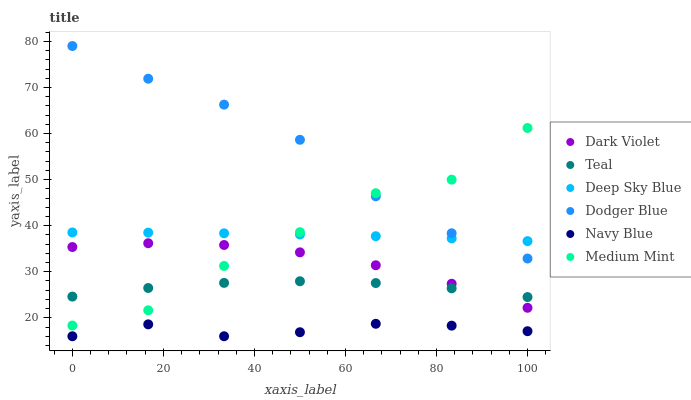Does Navy Blue have the minimum area under the curve?
Answer yes or no. Yes. Does Dodger Blue have the maximum area under the curve?
Answer yes or no. Yes. Does Teal have the minimum area under the curve?
Answer yes or no. No. Does Teal have the maximum area under the curve?
Answer yes or no. No. Is Deep Sky Blue the smoothest?
Answer yes or no. Yes. Is Medium Mint the roughest?
Answer yes or no. Yes. Is Teal the smoothest?
Answer yes or no. No. Is Teal the roughest?
Answer yes or no. No. Does Navy Blue have the lowest value?
Answer yes or no. Yes. Does Teal have the lowest value?
Answer yes or no. No. Does Dodger Blue have the highest value?
Answer yes or no. Yes. Does Teal have the highest value?
Answer yes or no. No. Is Navy Blue less than Medium Mint?
Answer yes or no. Yes. Is Deep Sky Blue greater than Navy Blue?
Answer yes or no. Yes. Does Medium Mint intersect Deep Sky Blue?
Answer yes or no. Yes. Is Medium Mint less than Deep Sky Blue?
Answer yes or no. No. Is Medium Mint greater than Deep Sky Blue?
Answer yes or no. No. Does Navy Blue intersect Medium Mint?
Answer yes or no. No. 